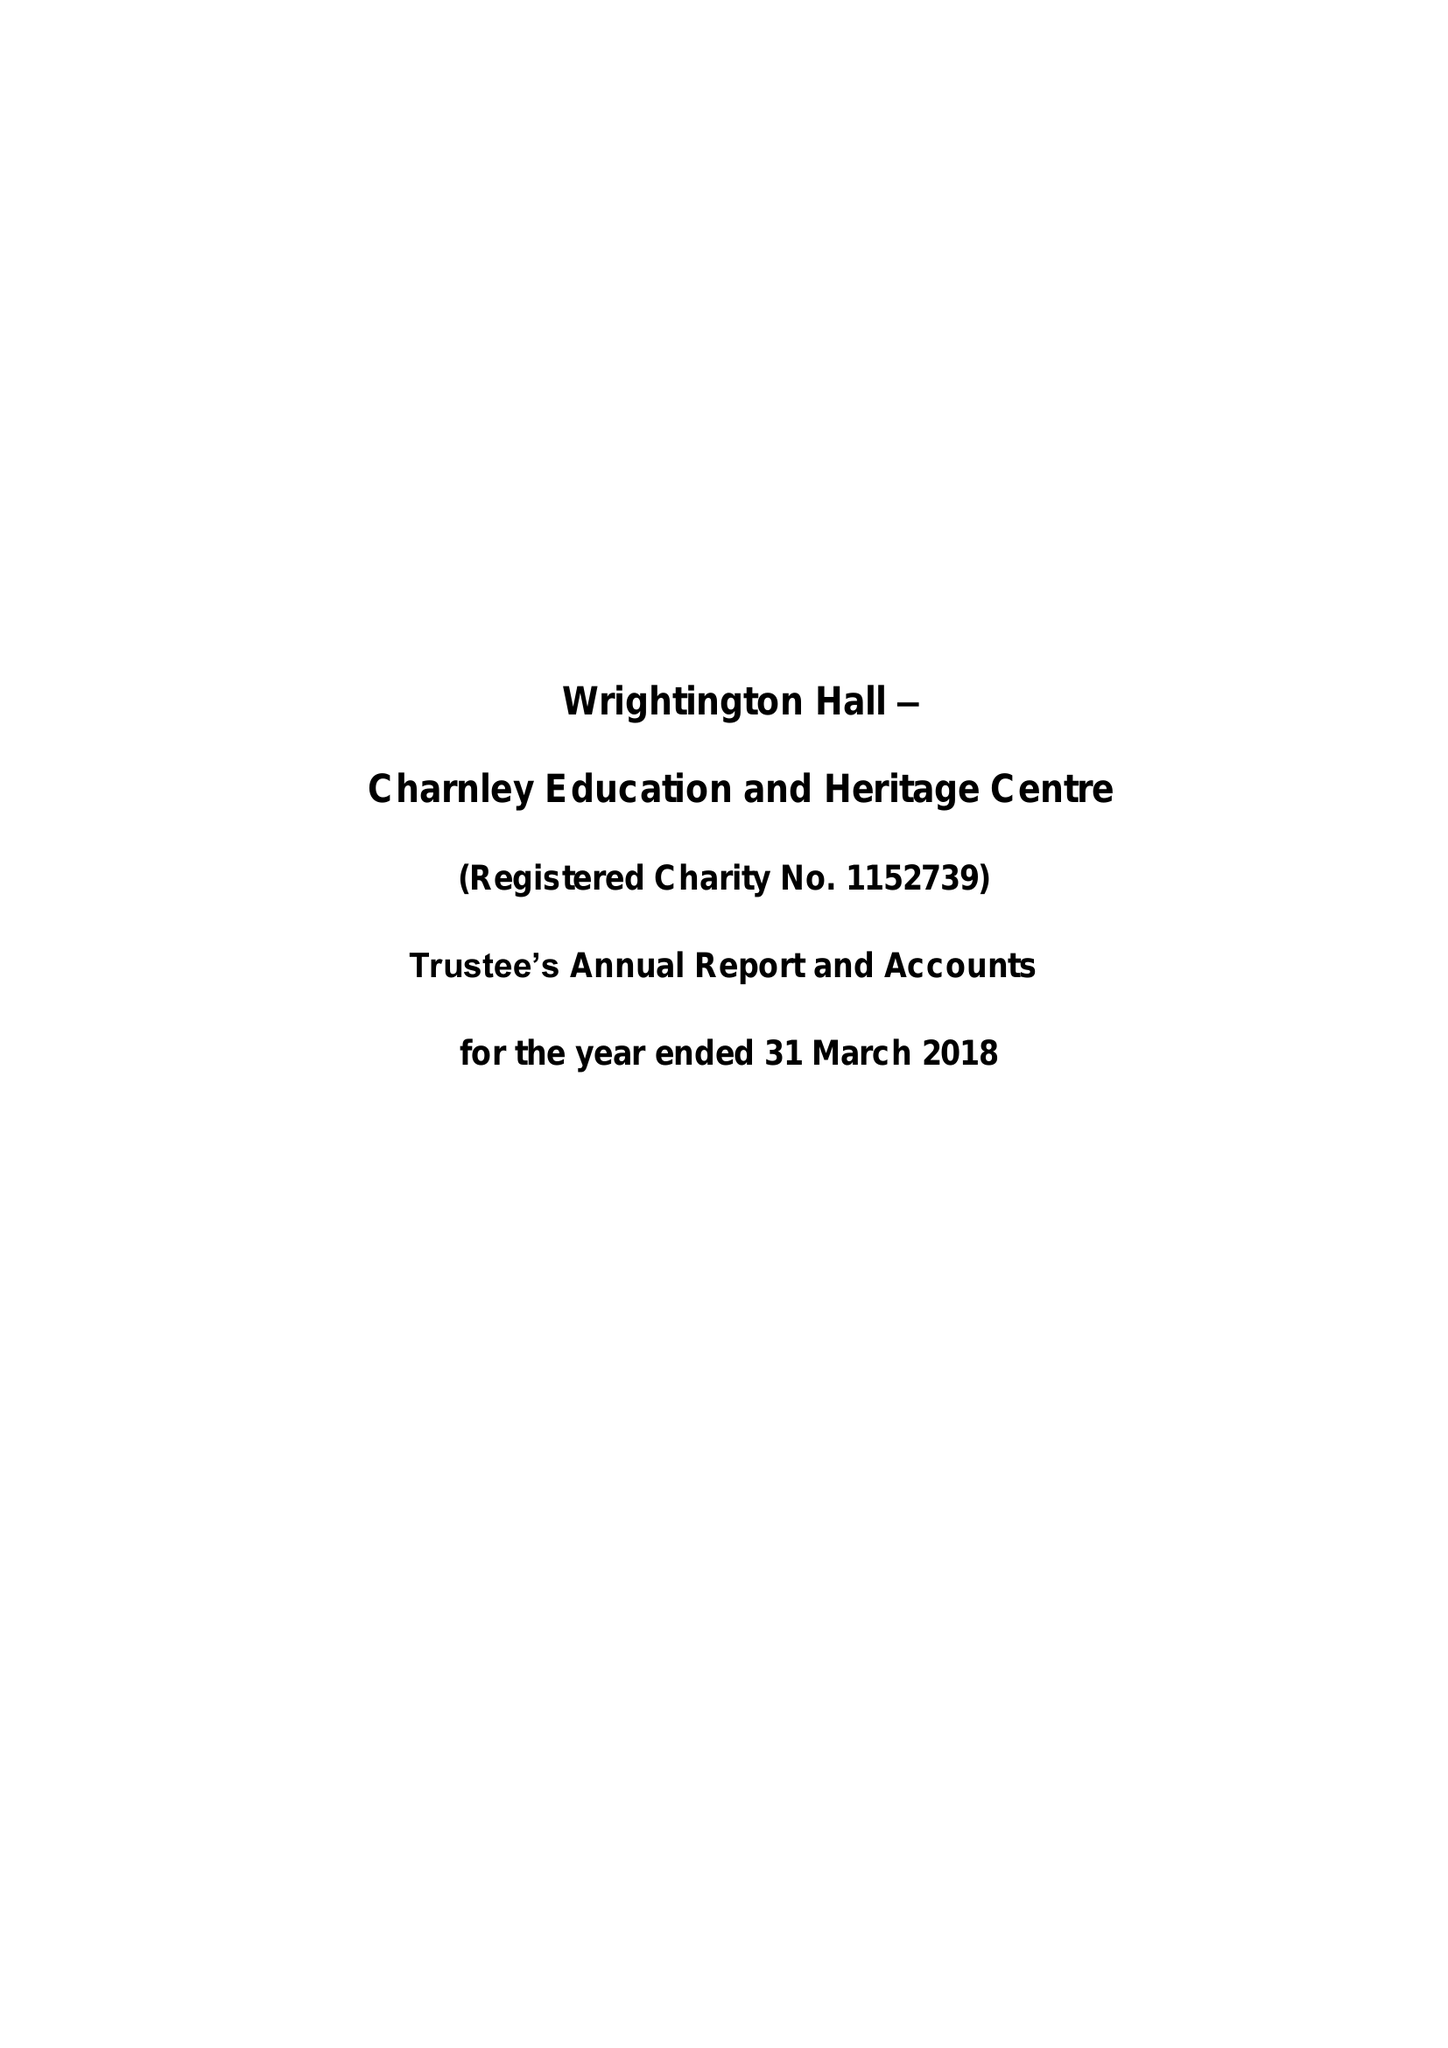What is the value for the charity_number?
Answer the question using a single word or phrase. 1152739 